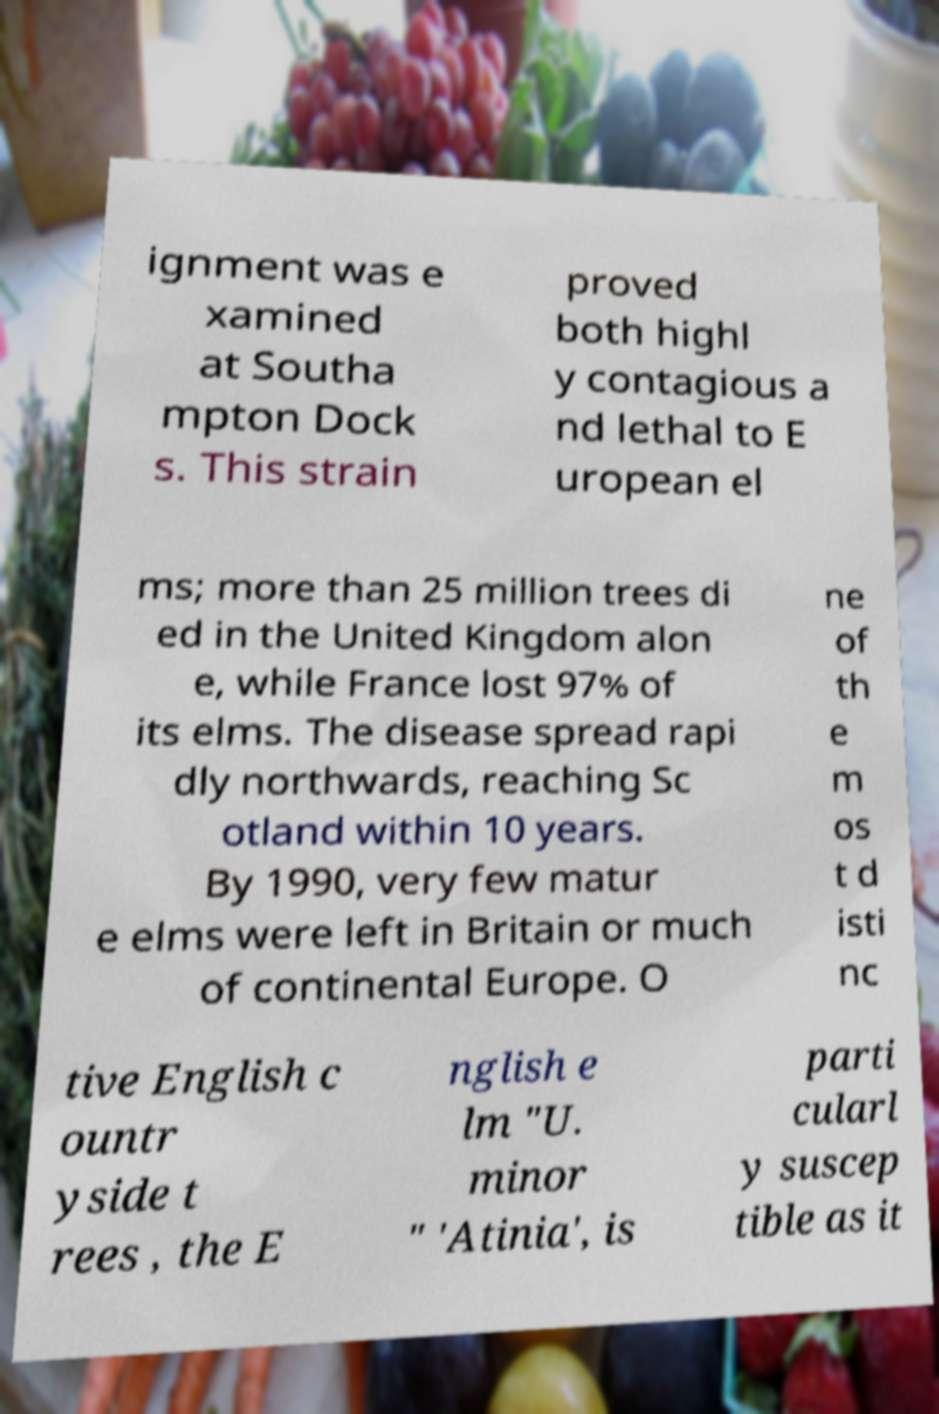What messages or text are displayed in this image? I need them in a readable, typed format. ignment was e xamined at Southa mpton Dock s. This strain proved both highl y contagious a nd lethal to E uropean el ms; more than 25 million trees di ed in the United Kingdom alon e, while France lost 97% of its elms. The disease spread rapi dly northwards, reaching Sc otland within 10 years. By 1990, very few matur e elms were left in Britain or much of continental Europe. O ne of th e m os t d isti nc tive English c ountr yside t rees , the E nglish e lm "U. minor " 'Atinia', is parti cularl y suscep tible as it 